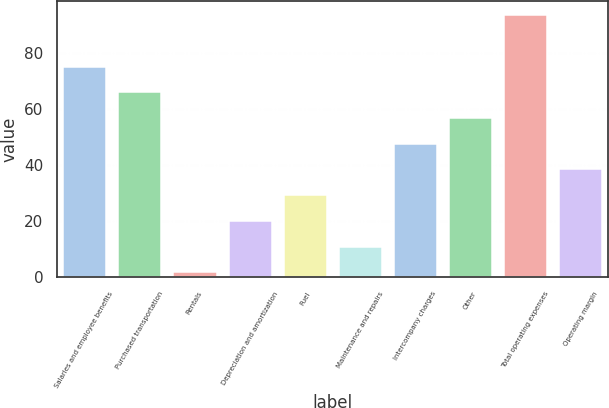Convert chart to OTSL. <chart><loc_0><loc_0><loc_500><loc_500><bar_chart><fcel>Salaries and employee benefits<fcel>Purchased transportation<fcel>Rentals<fcel>Depreciation and amortization<fcel>Fuel<fcel>Maintenance and repairs<fcel>Intercompany charges<fcel>Other<fcel>Total operating expenses<fcel>Operating margin<nl><fcel>75.32<fcel>66.18<fcel>2.2<fcel>20.48<fcel>29.62<fcel>11.34<fcel>47.9<fcel>57.04<fcel>93.6<fcel>38.76<nl></chart> 